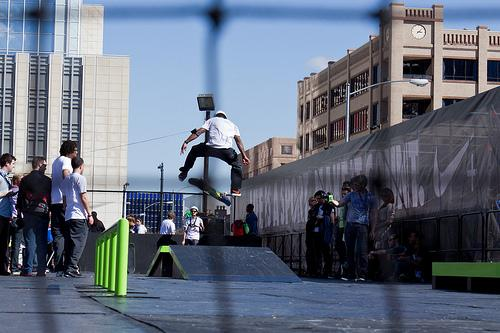Mention the activity of the main person featured in the image. The man is doing a skateboarding trick. Can you identify a logo and where it is placed in the image? There is a white Nike logo on a banner. What color is the pole described in the image? The pole is green. Explain the position of the skateboard in the image. The skateboard is in mid-air, reflecting the skateboarder performing a trick. Please provide a count of total spectators watching the skateboarder. There are 6 spectators watching the skateboarder. Briefly describe the environment that the skateboarder is performing in. The skateboarder is at an outdoor skate park with ramps, railings, and spectators watching. Explain the setting and the presence of any building in the image. The setting is outdoors with a tan building visible in the background. What color is the ramp that the skateboarder is utilizing in his trick? The ramp is black. List the colors of the clothes worn by the man doing the skateboard trick. The man is wearing a white shirt, jeans, and a hat. Describe the clock mentioned in the image. The clock is white and located on the side of a building. 